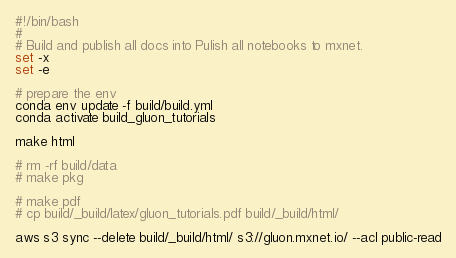Convert code to text. <code><loc_0><loc_0><loc_500><loc_500><_Bash_>#!/bin/bash
#
# Build and publish all docs into Pulish all notebooks to mxnet.
set -x
set -e

# prepare the env
conda env update -f build/build.yml
conda activate build_gluon_tutorials

make html

# rm -rf build/data
# make pkg

# make pdf
# cp build/_build/latex/gluon_tutorials.pdf build/_build/html/

aws s3 sync --delete build/_build/html/ s3://gluon.mxnet.io/ --acl public-read
</code> 